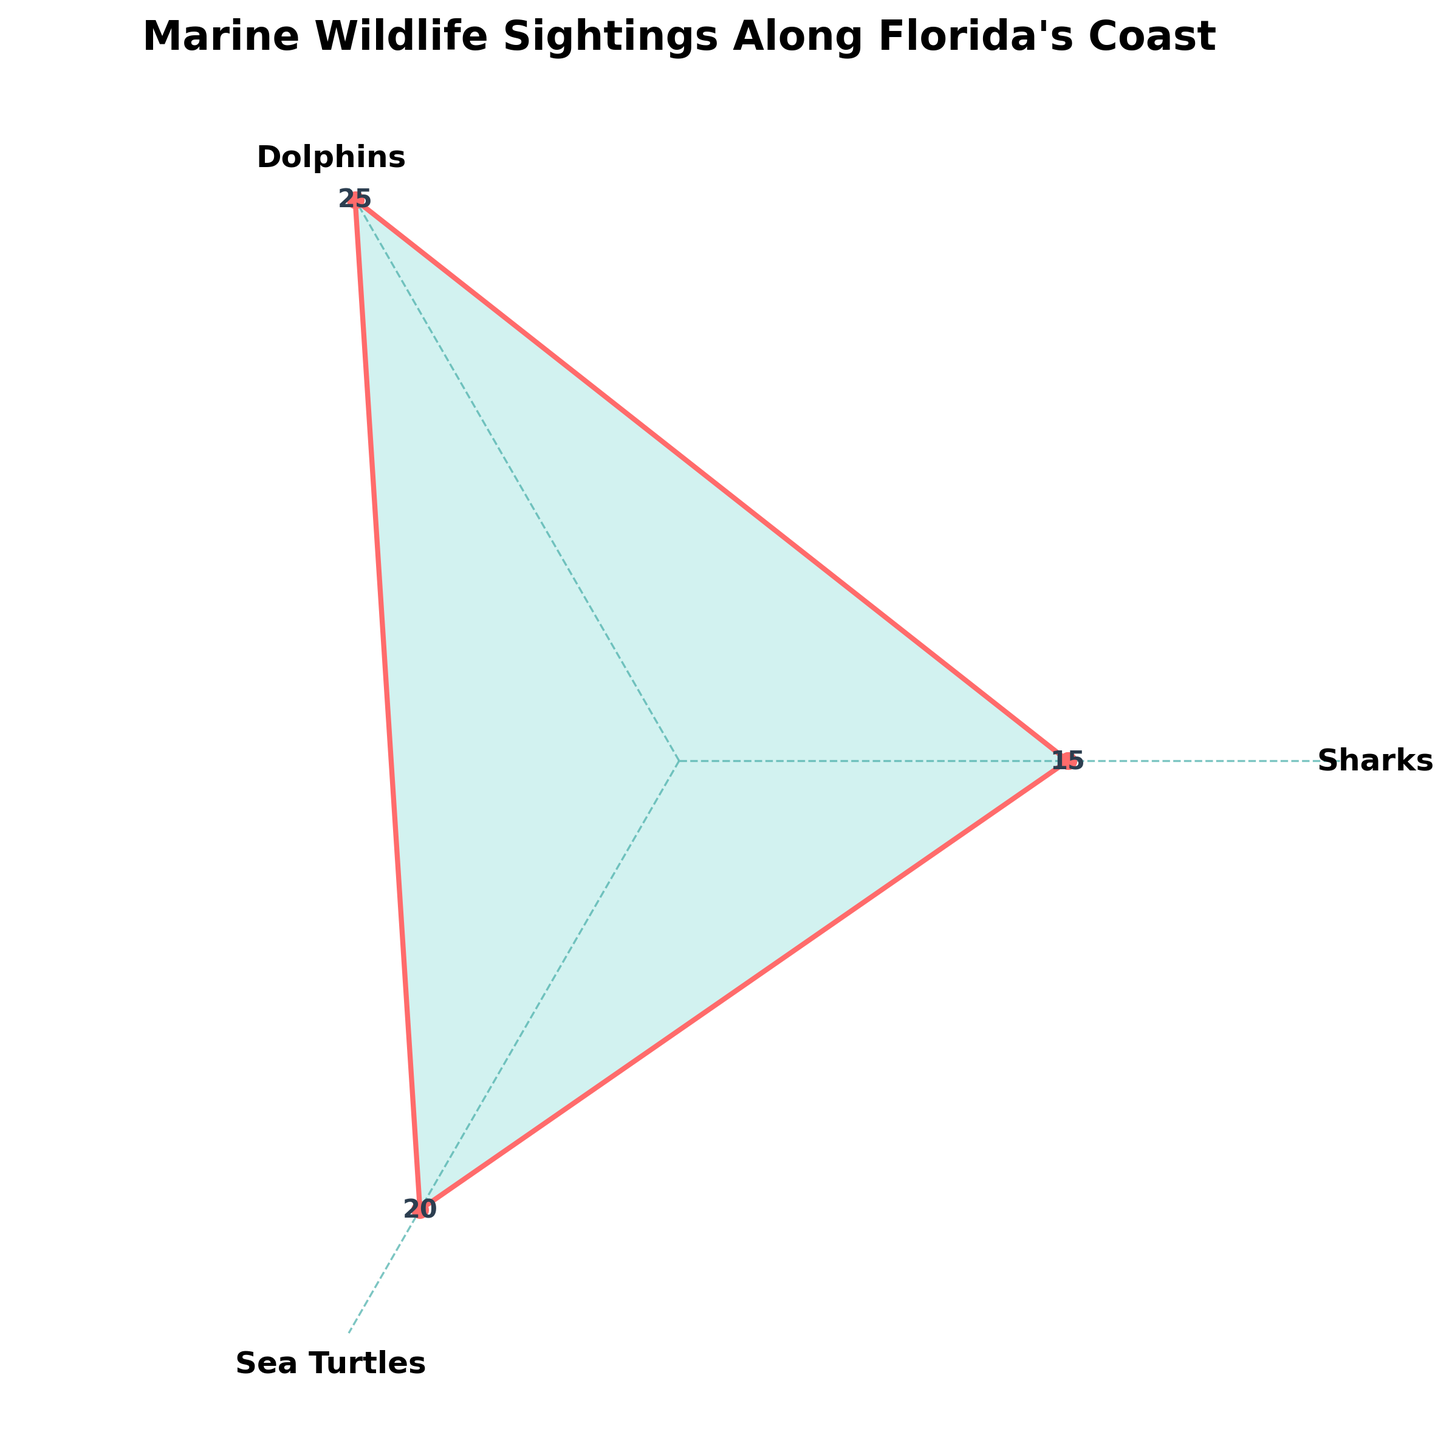how many different types of marine wildlife are represented in the chart? There are three distinct categories indicated by the angular tick labels on the plot: Sharks, Dolphins, and Sea Turtles.
Answer: 3 which category has the highest number of sightings? By looking at the values closest to the outer edge of the plot for each category, it's clear that Dolphins have the highest value at 25.
Answer: Dolphins what is the title of the figure? The title is found at the top of the plot and reads "Marine Wildlife Sightings Along Florida's Coast."
Answer: Marine Wildlife Sightings Along Florida's Coast how many sightings of sea turtles are recorded? The value next to the Sea Turtles label on the plot is 20.
Answer: 20 compare the number of sightings between sharks and dolphins. Dolphins have 25 sightings while Sharks have 15 sightings. Thus, Dolphins have 10 more sightings than Sharks.
Answer: Dolphins have 10 more sightings what color is used to fill the area under the plotted values? The area under the plotted values is filled with a light greenish color.
Answer: Light green are there any categories that have the same number of sightings? By checking the values on the plot, we can see that all three categories have different values: 15 for Sharks, 25 for Dolphins, and 20 for Sea Turtles.
Answer: No what is the total number of marine wildlife sightings recorded in this chart? The total is the sum of all the sightings: 15 (Sharks) + 25 (Dolphins) + 20 (Sea Turtles) = 60.
Answer: 60 what is the average number of sightings across all categories? To find the average, sum up all sightings (15 + 25 + 20 = 60) and divide by the number of categories (3). The average is 60 / 3 = 20.
Answer: 20 which category has the smallest number of sightings? Looking at the values next to each label, Sharks have the smallest number of sightings with 15.
Answer: Sharks 